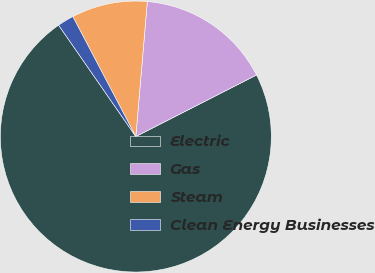Convert chart. <chart><loc_0><loc_0><loc_500><loc_500><pie_chart><fcel>Electric<fcel>Gas<fcel>Steam<fcel>Clean Energy Businesses<nl><fcel>72.86%<fcel>16.14%<fcel>9.05%<fcel>1.95%<nl></chart> 